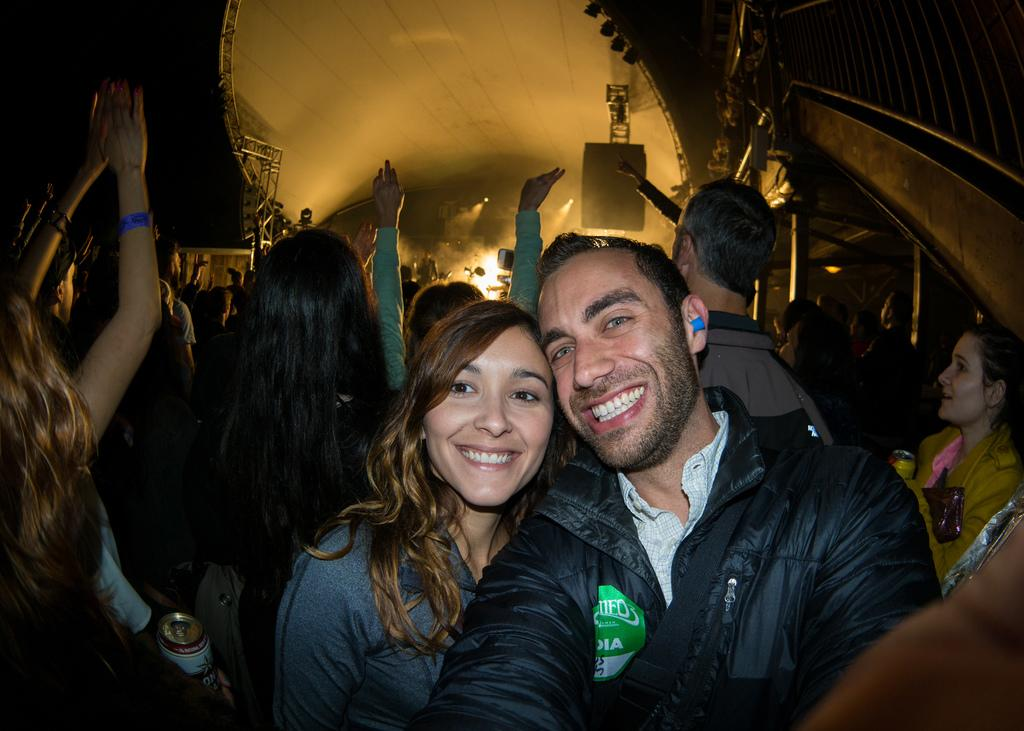Who is present in the image? There is a man and a woman in the image. What are the man and woman doing in the image? The man and woman are taking a picture. Can you describe the background of the image? There are people in the background of the image. What else can be seen in the image? There are lights visible in the image. What type of selection is being made by the man and woman in the image? There is no indication in the image that the man and woman are making a selection; they are taking a picture. 